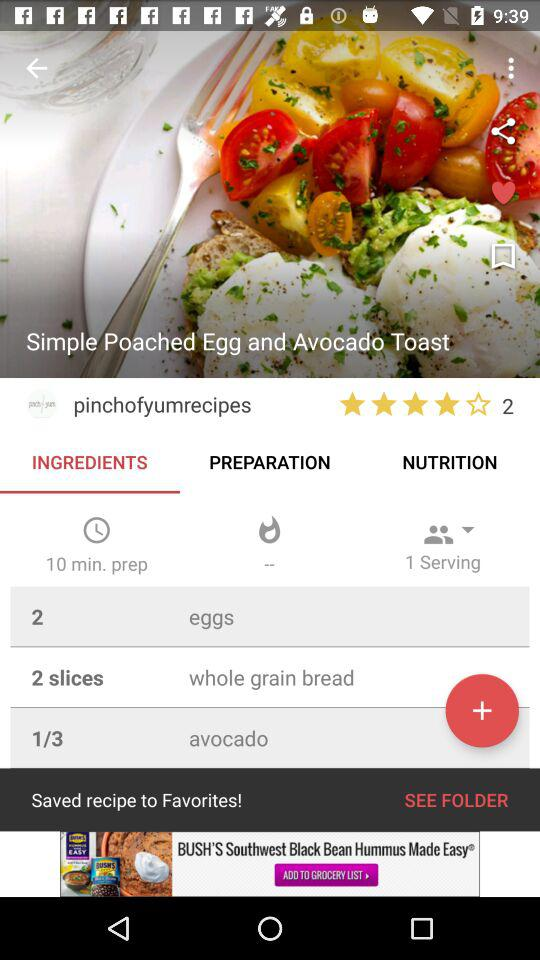How many ingredients are in this recipe?
Answer the question using a single word or phrase. 3 